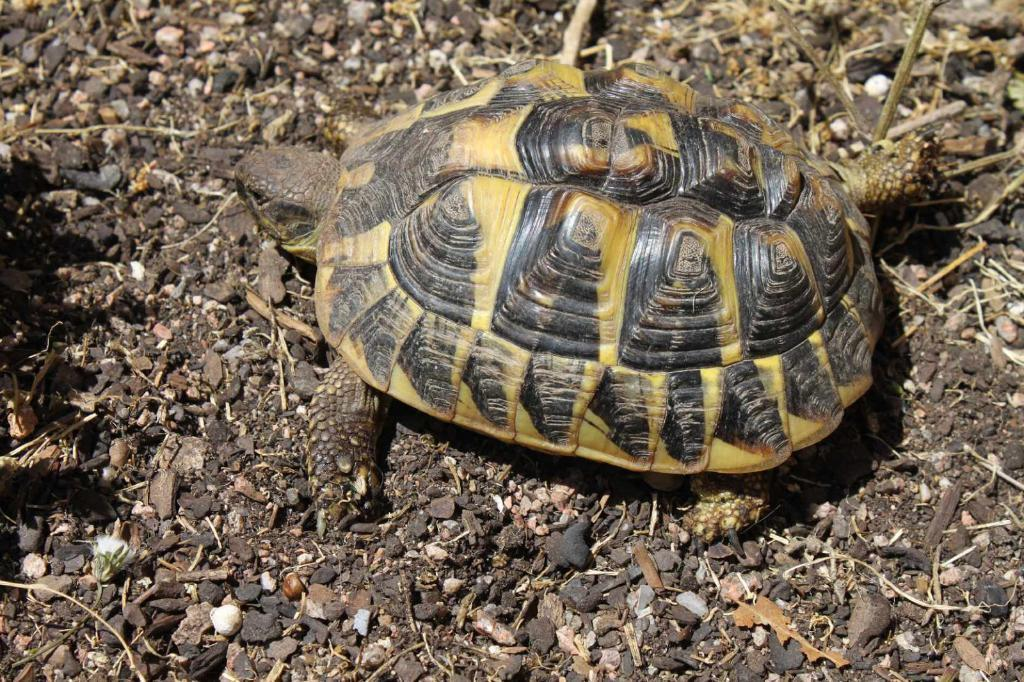What animal is present in the image? There is a tortoise in the image. What is the tortoise standing on? The tortoise is on the soil in the image. What other objects can be seen in the image? There are stones in the image. What type of chin ornament is the tortoise wearing in the image? There is no chin ornament present on the tortoise in the image. How many quills does the tortoise have in the image? Tortoises do not have quills; they have a hard shell covering their body. 